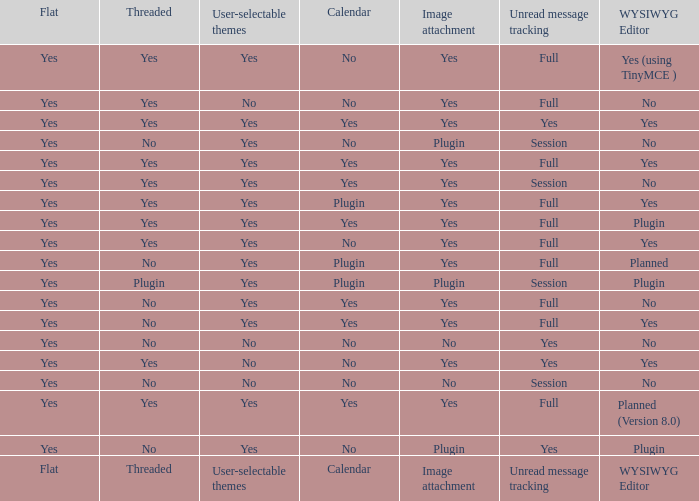Which Calendar has a WYSIWYG Editor of no, and an Unread message tracking of session, and an Image attachment of no? No. 